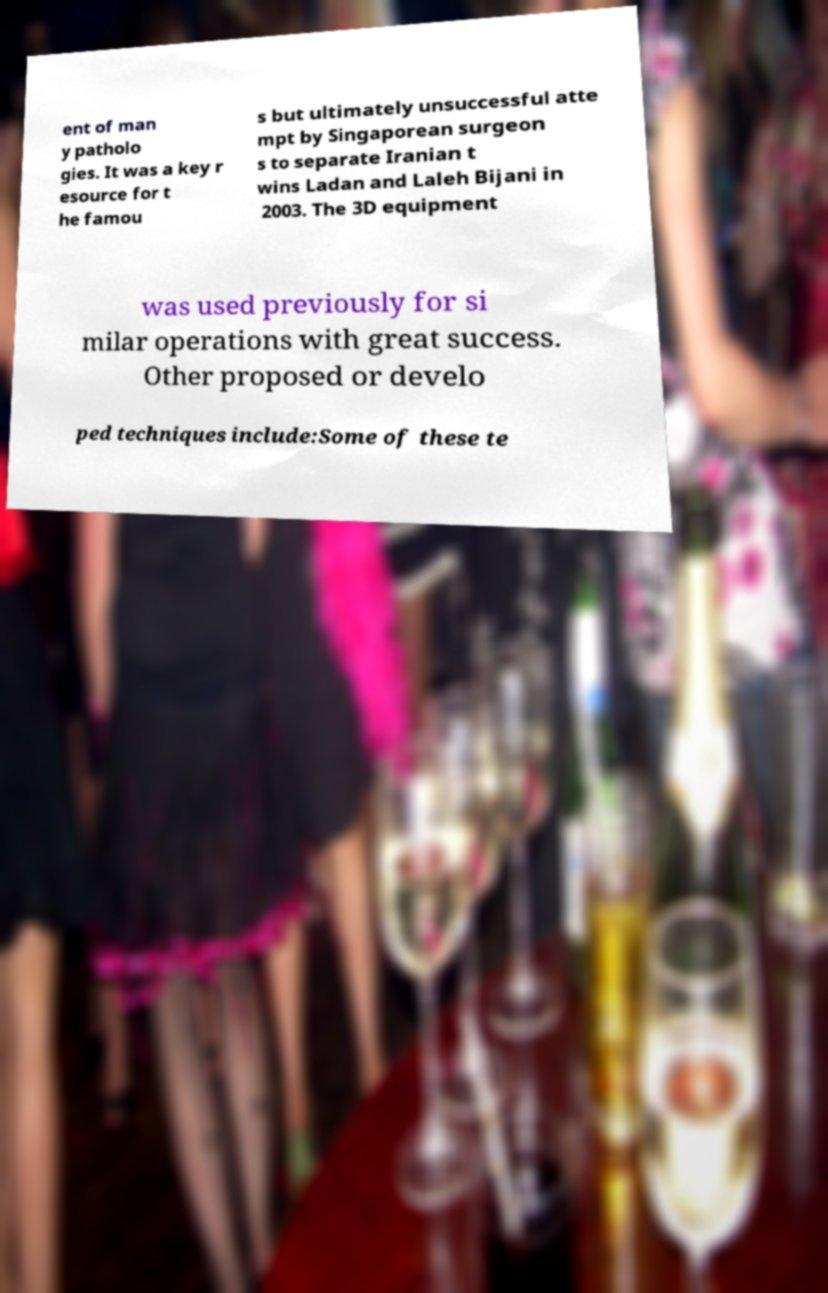Could you extract and type out the text from this image? ent of man y patholo gies. It was a key r esource for t he famou s but ultimately unsuccessful atte mpt by Singaporean surgeon s to separate Iranian t wins Ladan and Laleh Bijani in 2003. The 3D equipment was used previously for si milar operations with great success. Other proposed or develo ped techniques include:Some of these te 